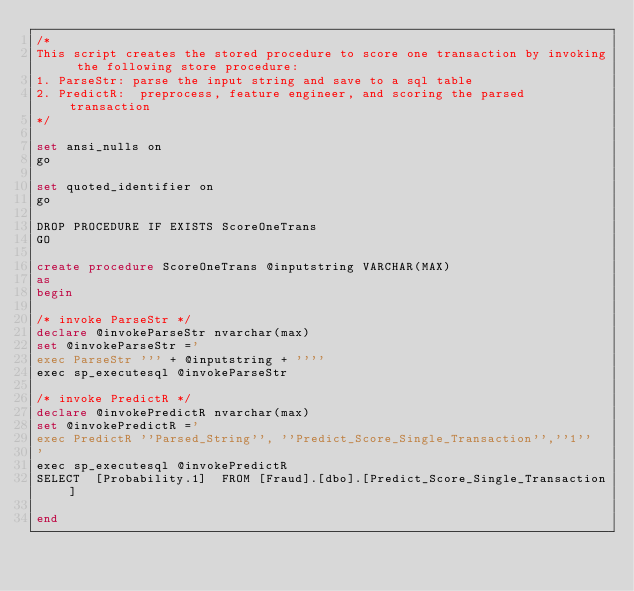<code> <loc_0><loc_0><loc_500><loc_500><_SQL_>/*
This script creates the stored procedure to score one transaction by invoking the following store procedure:
1. ParseStr: parse the input string and save to a sql table
2. PredictR:  preprocess, feature engineer, and scoring the parsed transaction
*/

set ansi_nulls on
go

set quoted_identifier on
go

DROP PROCEDURE IF EXISTS ScoreOneTrans
GO

create procedure ScoreOneTrans @inputstring VARCHAR(MAX)
as
begin

/* invoke ParseStr */
declare @invokeParseStr nvarchar(max)
set @invokeParseStr ='
exec ParseStr ''' + @inputstring + ''''
exec sp_executesql @invokeParseStr

/* invoke PredictR */
declare @invokePredictR nvarchar(max)
set @invokePredictR ='
exec PredictR ''Parsed_String'', ''Predict_Score_Single_Transaction'',''1''
'
exec sp_executesql @invokePredictR
SELECT  [Probability.1]  FROM [Fraud].[dbo].[Predict_Score_Single_Transaction]

end </code> 